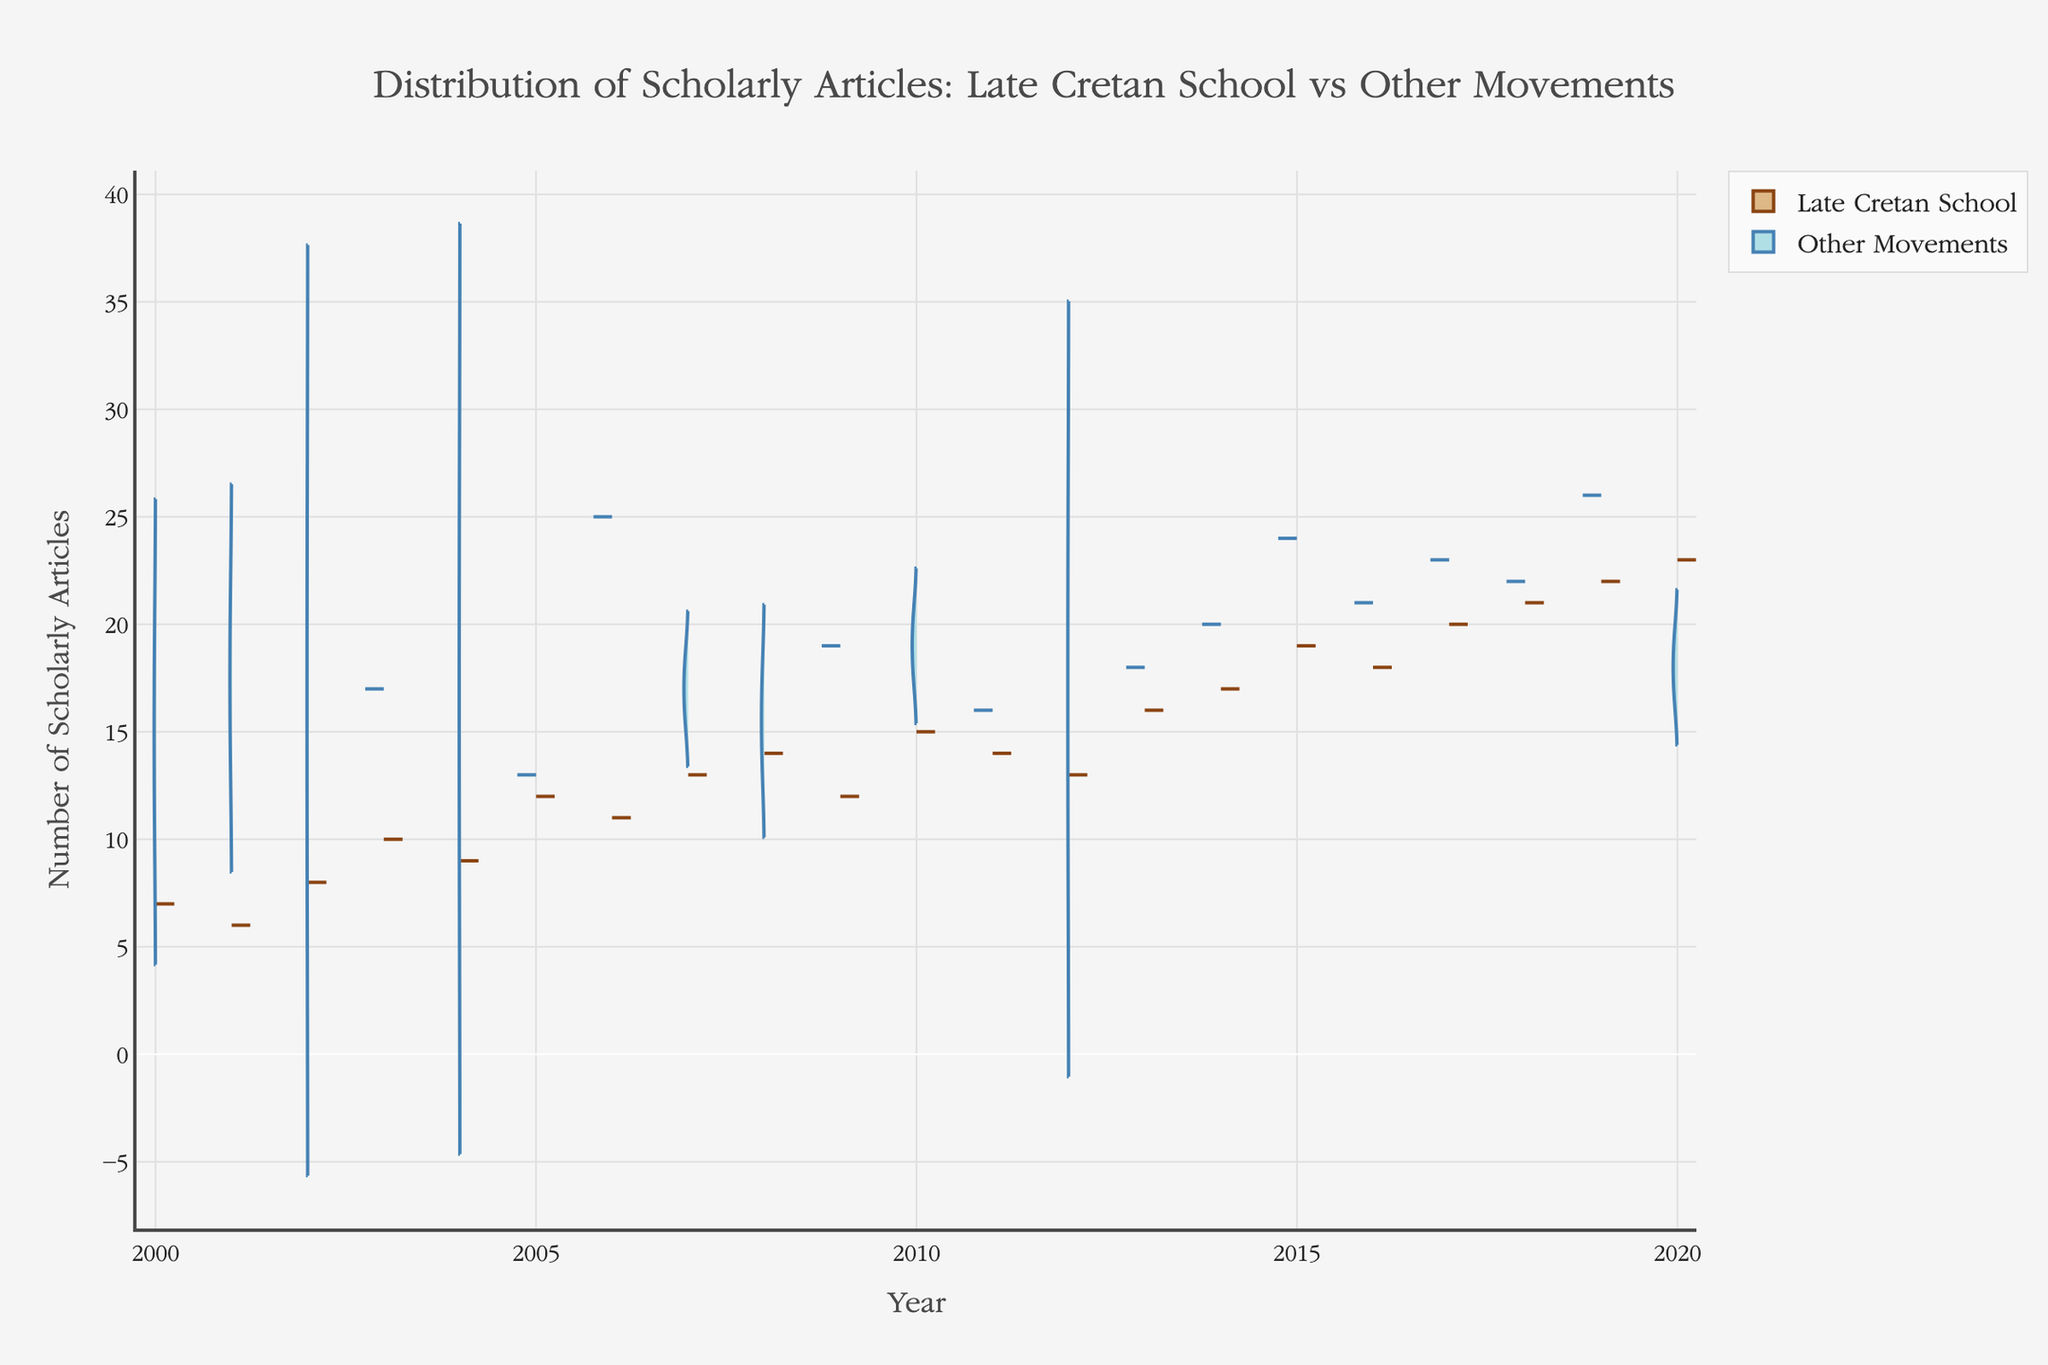What are the colors used to represent the Late Cretan School and other movements? The Late Cretan School is represented with a brown color, while other movements are depicted using a blue color. This can be inferred from the violin sections’ different fill and line colors.
Answer: Brown and Blue What is the title of the figure? The title is usually located prominently at the top of the figure. In this case, it reads "Distribution of Scholarly Articles: Late Cretan School vs Other Movements".
Answer: Distribution of Scholarly Articles: Late Cretan School vs Other Movements Which year had the highest number of scholarly articles published on the Late Cretan School? By examining the positive side of the violin plot, the peak year with the highest number of scholarly articles for the Late Cretan School can be identified as 2020.
Answer: 2020 How many different art movements other than the Late Cretan School are included in the chart? A review of the legend and the negative sides of the violins showing 'Other Movements' reveals five categories: Renaissance, Baroque, Impressionism, Mannerism, and a generalized category for 'Other Movements'.
Answer: Five In 2016, how does the number of scholarly articles for the Late Cretan School compare to those for Baroque? By locating 2016 on the x-axis and comparing the height of the violins, one can see that the number of scholarly articles on the Late Cretan School exceeds those on Baroque. Specifically, the Late Cretan School has more articles published than Baroque in that year.
Answer: Late Cretan School has more Between 2015 and 2020, which art movement consistently has more scholarly articles published: the Late Cretan School or the Renaissance? By examining the years 2015 to 2020 and comparing the heights of the violins for both movements across these years, it is evident that the Renaissance has more scholarly articles published in 2015, 2017, 2018, and 2019, but the Late Cretan School surpasses in 2016 and 2020.
Answer: Renaissance overall What trend can be observed for the number of scholarly articles on the Late Cretan School between 2000 and 2020? By examining the positive side of the violin plot, it is observable that the number of scholarly articles on the Late Cretan School generally increases over the years from 2000 to 2020.
Answer: Increasing trend How many scholarly articles on Baroque were published in the year 2013? By locating the year 2013 on the x-axis and examining the negative side representing the Baroque movement, one identifies that there are 18 scholarly articles.
Answer: 18 What is the average number of scholarly articles published annually for the Late Cretan School between 2000 and 2020? To calculate the average, sum the numbers of scholarly articles annually for the Late Cretan School from 2000 to 2020, and then divide by the total number of years. (7+6+8+10+9+12+11+13+14+12+15+14+13+16+17+19+18+20+21+22+23)/21 = 14.81.
Answer: 14.81 